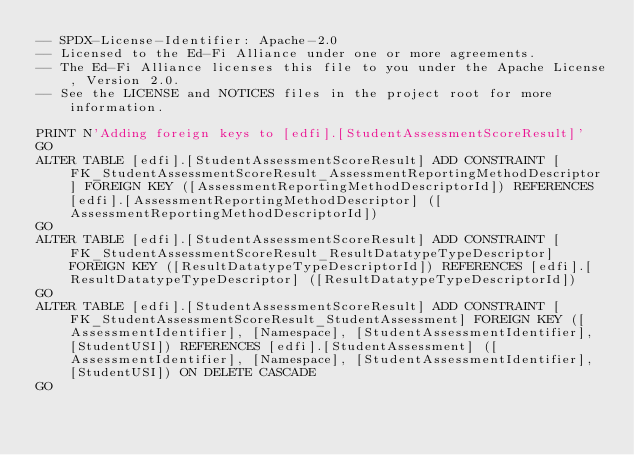<code> <loc_0><loc_0><loc_500><loc_500><_SQL_>-- SPDX-License-Identifier: Apache-2.0
-- Licensed to the Ed-Fi Alliance under one or more agreements.
-- The Ed-Fi Alliance licenses this file to you under the Apache License, Version 2.0.
-- See the LICENSE and NOTICES files in the project root for more information.

PRINT N'Adding foreign keys to [edfi].[StudentAssessmentScoreResult]'
GO
ALTER TABLE [edfi].[StudentAssessmentScoreResult] ADD CONSTRAINT [FK_StudentAssessmentScoreResult_AssessmentReportingMethodDescriptor] FOREIGN KEY ([AssessmentReportingMethodDescriptorId]) REFERENCES [edfi].[AssessmentReportingMethodDescriptor] ([AssessmentReportingMethodDescriptorId])
GO
ALTER TABLE [edfi].[StudentAssessmentScoreResult] ADD CONSTRAINT [FK_StudentAssessmentScoreResult_ResultDatatypeTypeDescriptor] FOREIGN KEY ([ResultDatatypeTypeDescriptorId]) REFERENCES [edfi].[ResultDatatypeTypeDescriptor] ([ResultDatatypeTypeDescriptorId])
GO
ALTER TABLE [edfi].[StudentAssessmentScoreResult] ADD CONSTRAINT [FK_StudentAssessmentScoreResult_StudentAssessment] FOREIGN KEY ([AssessmentIdentifier], [Namespace], [StudentAssessmentIdentifier], [StudentUSI]) REFERENCES [edfi].[StudentAssessment] ([AssessmentIdentifier], [Namespace], [StudentAssessmentIdentifier], [StudentUSI]) ON DELETE CASCADE
GO
</code> 